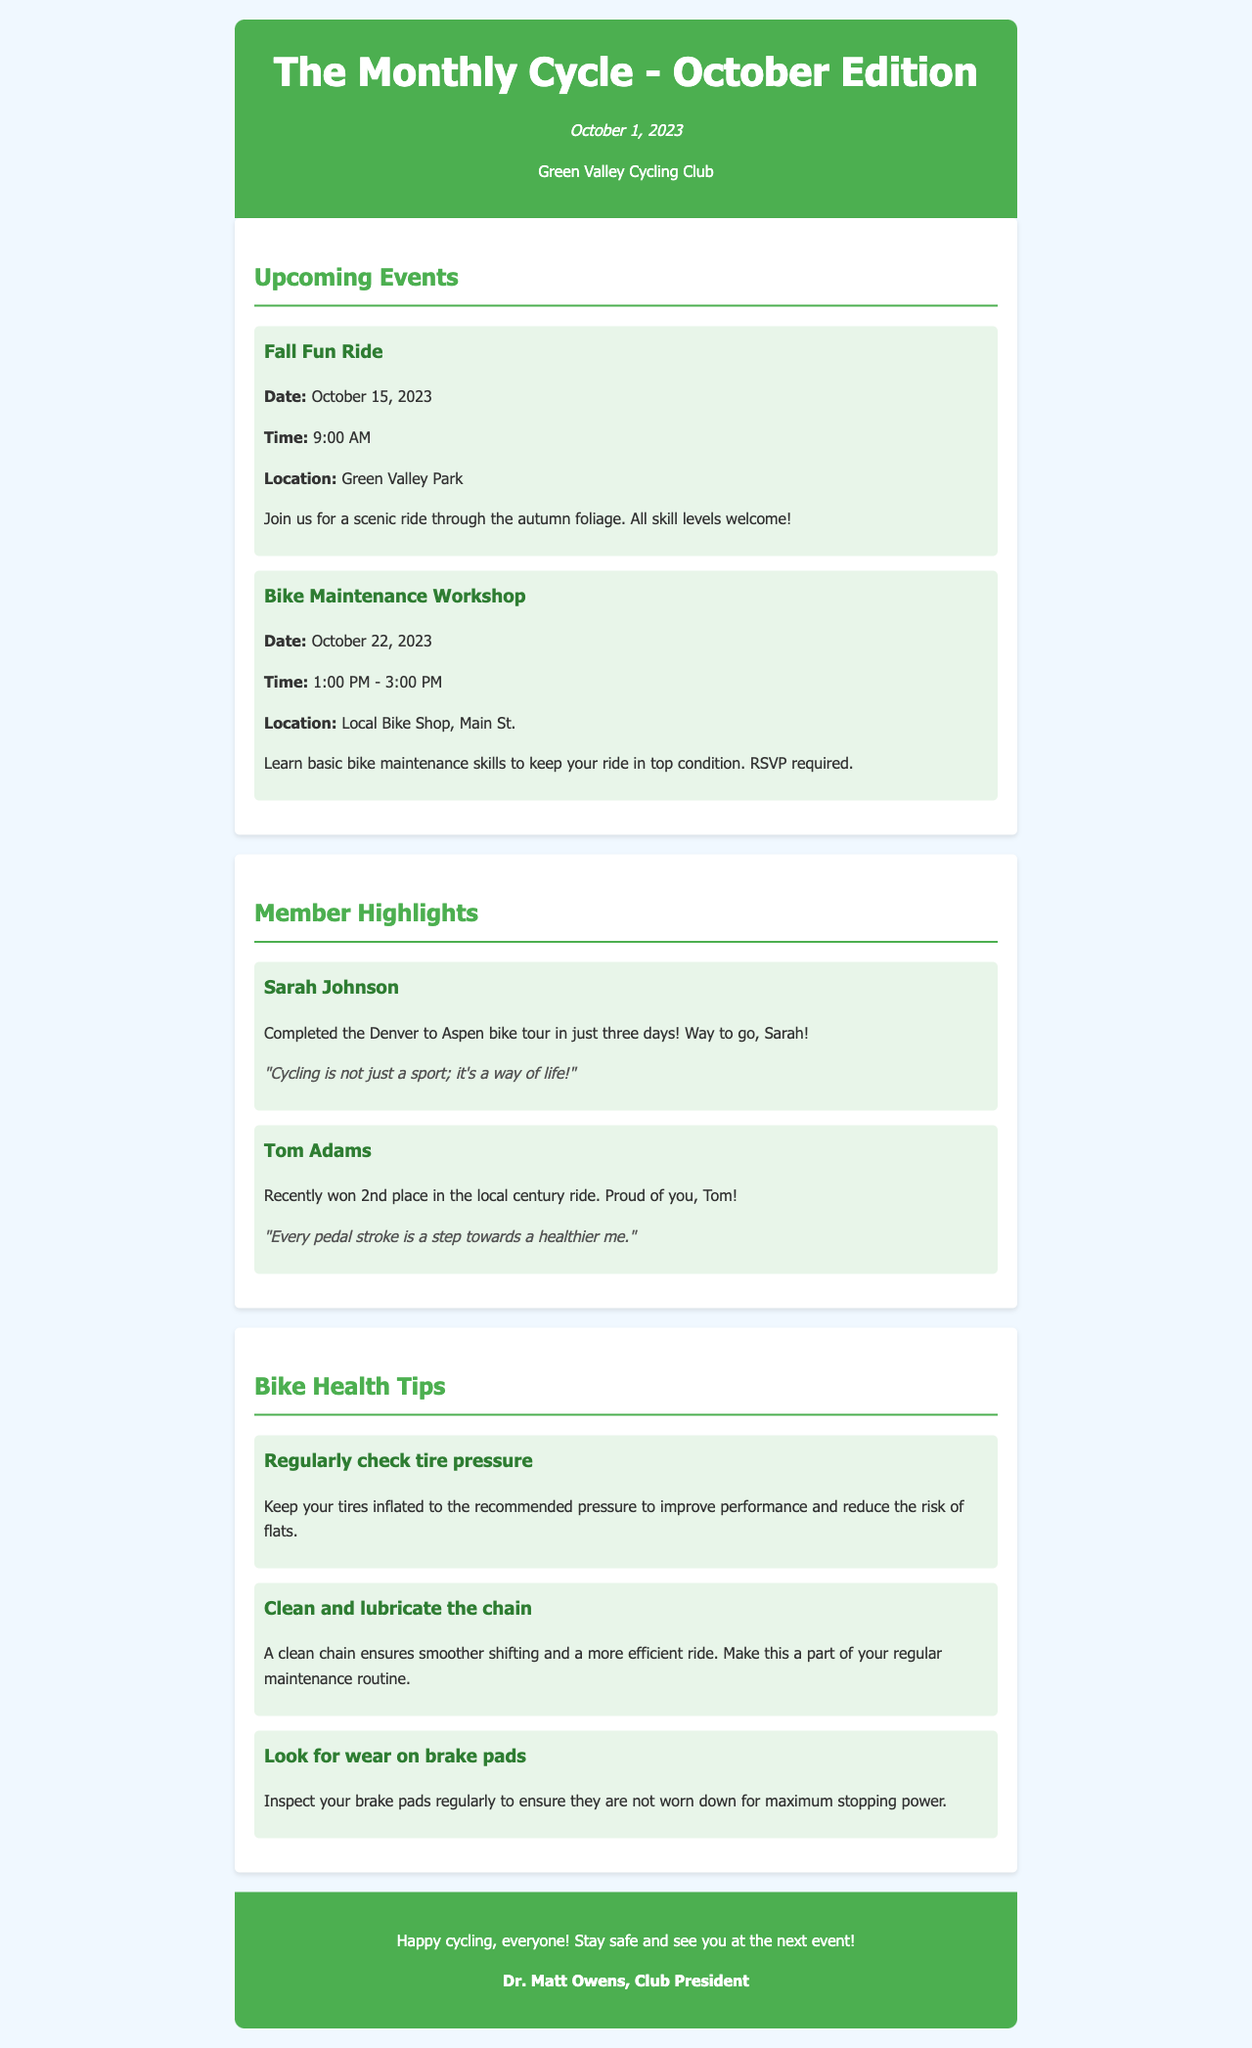What is the title of the newsletter? The title of the newsletter is found in the header section of the document, which clearly states "The Monthly Cycle - October Edition."
Answer: The Monthly Cycle - October Edition What date is the newsletter published? The date is provided in the header as part of the newsletter's publication information.
Answer: October 1, 2023 When is the Fall Fun Ride scheduled? The specific date for the Fall Fun Ride can be found under the Upcoming Events section.
Answer: October 15, 2023 Where is the Bike Maintenance Workshop taking place? The location for the workshop is mentioned in the event details within the Upcoming Events section.
Answer: Local Bike Shop, Main St Who won 2nd place in the local century ride? The name of the member who won 2nd place is detailed in the Member Highlights section.
Answer: Tom Adams What is one of the bike health tips provided? The document includes specific advice under the Bike Health Tips section, such as regular maintenance suggestions.
Answer: Regularly check tire pressure How many members are highlighted in the newsletter? The number of members highlighted can be counted in the Member Highlights section.
Answer: Two What is a reason for inspecting brake pads? The document provides a reason for maintaining brake pads under the Bike Health Tips section.
Answer: Maximum stopping power What tone does the president conclude the newsletter with? The closing remarks can be found in the footer, indicating the overall tone of the message.
Answer: Positive and encouraging 